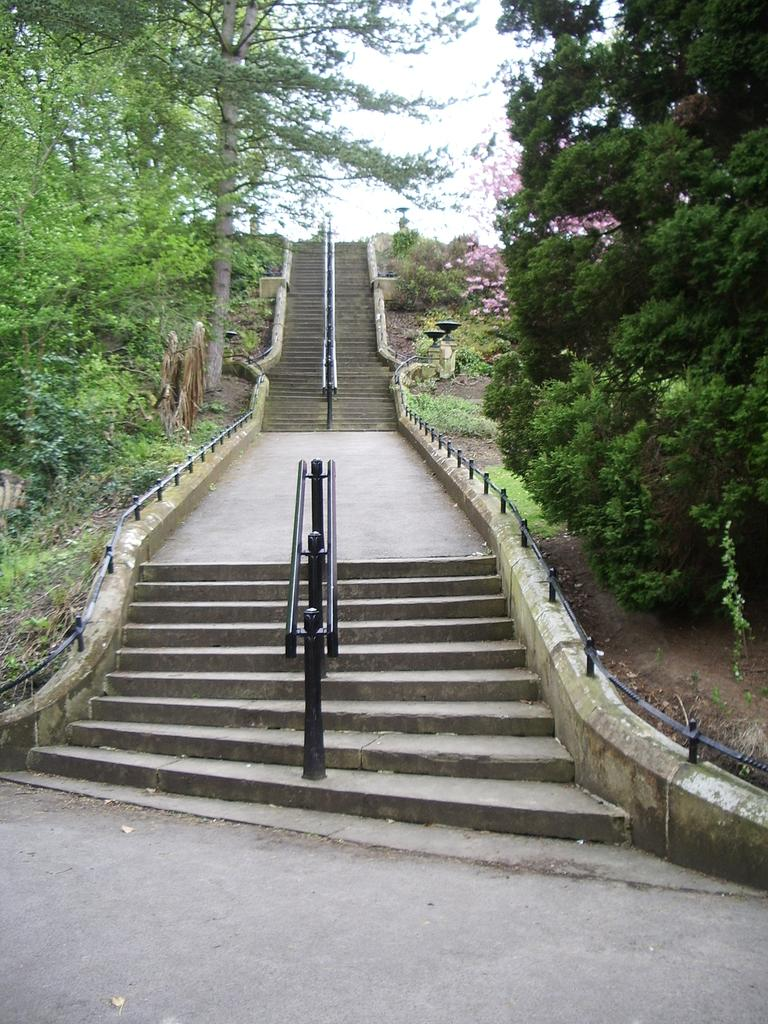What type of structure is present in the image? There are: There are stairs in the image. What feature is present on the stairs? There is a metal railing on the stairs. What natural elements can be seen in the image? Trees are visible in the image. How would you describe the weather based on the image? The sky is cloudy in the image. How many children are playing with wax on the stairs in the image? There are no children or wax present in the image. 